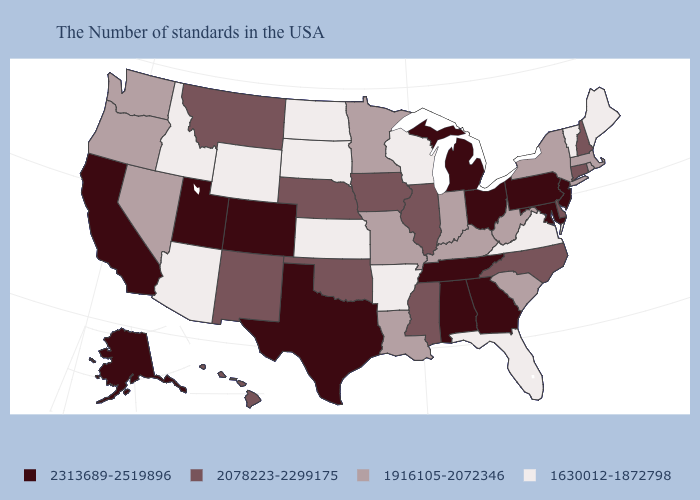Which states have the lowest value in the MidWest?
Quick response, please. Wisconsin, Kansas, South Dakota, North Dakota. Is the legend a continuous bar?
Short answer required. No. Which states have the highest value in the USA?
Answer briefly. New Jersey, Maryland, Pennsylvania, Ohio, Georgia, Michigan, Alabama, Tennessee, Texas, Colorado, Utah, California, Alaska. What is the value of Maine?
Be succinct. 1630012-1872798. Does Connecticut have a higher value than North Dakota?
Short answer required. Yes. Name the states that have a value in the range 1916105-2072346?
Answer briefly. Massachusetts, Rhode Island, New York, South Carolina, West Virginia, Kentucky, Indiana, Louisiana, Missouri, Minnesota, Nevada, Washington, Oregon. What is the value of North Carolina?
Be succinct. 2078223-2299175. Name the states that have a value in the range 1630012-1872798?
Keep it brief. Maine, Vermont, Virginia, Florida, Wisconsin, Arkansas, Kansas, South Dakota, North Dakota, Wyoming, Arizona, Idaho. What is the value of Indiana?
Short answer required. 1916105-2072346. Among the states that border Oklahoma , does Kansas have the lowest value?
Give a very brief answer. Yes. Does the first symbol in the legend represent the smallest category?
Keep it brief. No. Does Michigan have a higher value than Nevada?
Give a very brief answer. Yes. Name the states that have a value in the range 1916105-2072346?
Give a very brief answer. Massachusetts, Rhode Island, New York, South Carolina, West Virginia, Kentucky, Indiana, Louisiana, Missouri, Minnesota, Nevada, Washington, Oregon. What is the value of Alabama?
Give a very brief answer. 2313689-2519896. 